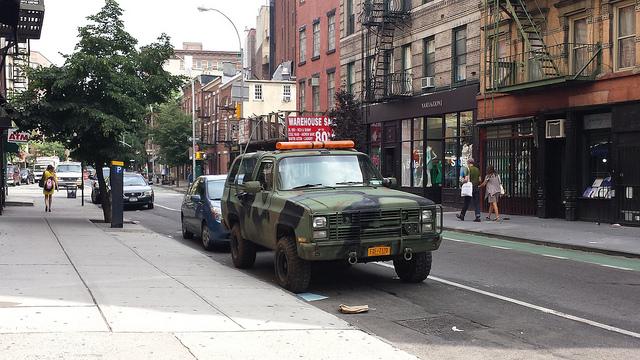What is the design of the paint on the closest vehicle called?
Quick response, please. Camouflage. Is this a rural area?
Be succinct. No. What time of year was this picture most likely taken?
Give a very brief answer. Summer. Are the people going for a walk?
Quick response, please. Yes. 